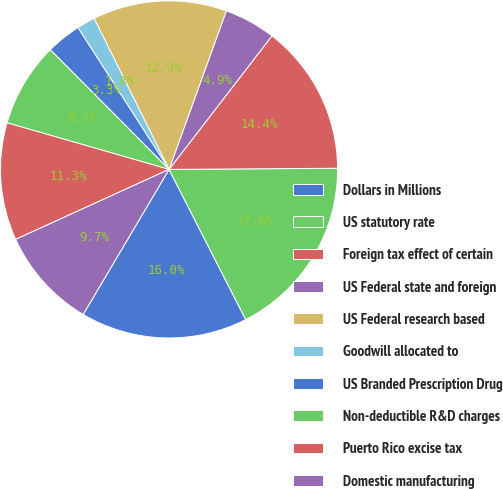<chart> <loc_0><loc_0><loc_500><loc_500><pie_chart><fcel>Dollars in Millions<fcel>US statutory rate<fcel>Foreign tax effect of certain<fcel>US Federal state and foreign<fcel>US Federal research based<fcel>Goodwill allocated to<fcel>US Branded Prescription Drug<fcel>Non-deductible R&D charges<fcel>Puerto Rico excise tax<fcel>Domestic manufacturing<nl><fcel>16.02%<fcel>17.6%<fcel>14.44%<fcel>4.93%<fcel>12.85%<fcel>1.76%<fcel>3.35%<fcel>8.1%<fcel>11.27%<fcel>9.68%<nl></chart> 